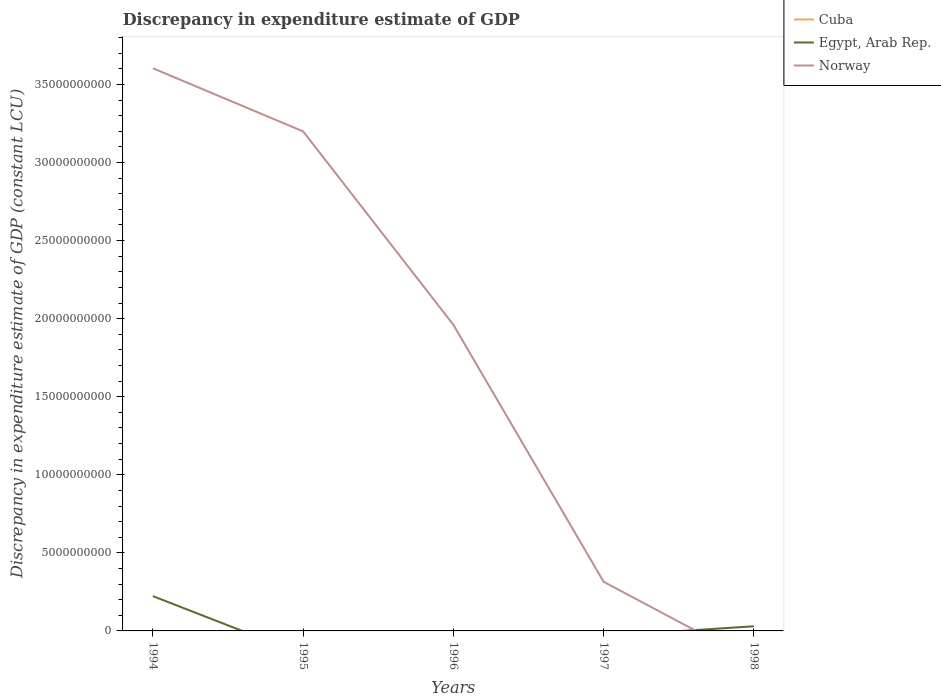How many different coloured lines are there?
Your response must be concise. 2. What is the total discrepancy in expenditure estimate of GDP in Norway in the graph?
Make the answer very short. 3.29e+1. What is the difference between the highest and the second highest discrepancy in expenditure estimate of GDP in Egypt, Arab Rep.?
Provide a succinct answer. 2.23e+09. What is the difference between the highest and the lowest discrepancy in expenditure estimate of GDP in Norway?
Keep it short and to the point. 3. Is the discrepancy in expenditure estimate of GDP in Egypt, Arab Rep. strictly greater than the discrepancy in expenditure estimate of GDP in Norway over the years?
Your answer should be very brief. No. How many lines are there?
Your response must be concise. 2. How many years are there in the graph?
Provide a succinct answer. 5. What is the difference between two consecutive major ticks on the Y-axis?
Offer a terse response. 5.00e+09. Are the values on the major ticks of Y-axis written in scientific E-notation?
Give a very brief answer. No. Does the graph contain any zero values?
Your response must be concise. Yes. Does the graph contain grids?
Provide a short and direct response. No. Where does the legend appear in the graph?
Make the answer very short. Top right. What is the title of the graph?
Offer a terse response. Discrepancy in expenditure estimate of GDP. What is the label or title of the X-axis?
Keep it short and to the point. Years. What is the label or title of the Y-axis?
Offer a terse response. Discrepancy in expenditure estimate of GDP (constant LCU). What is the Discrepancy in expenditure estimate of GDP (constant LCU) of Egypt, Arab Rep. in 1994?
Make the answer very short. 2.23e+09. What is the Discrepancy in expenditure estimate of GDP (constant LCU) in Norway in 1994?
Keep it short and to the point. 3.60e+1. What is the Discrepancy in expenditure estimate of GDP (constant LCU) in Cuba in 1995?
Your answer should be compact. 0. What is the Discrepancy in expenditure estimate of GDP (constant LCU) of Norway in 1995?
Your answer should be compact. 3.20e+1. What is the Discrepancy in expenditure estimate of GDP (constant LCU) of Cuba in 1996?
Ensure brevity in your answer.  0. What is the Discrepancy in expenditure estimate of GDP (constant LCU) in Norway in 1996?
Offer a very short reply. 1.96e+1. What is the Discrepancy in expenditure estimate of GDP (constant LCU) in Cuba in 1997?
Your answer should be compact. 0. What is the Discrepancy in expenditure estimate of GDP (constant LCU) in Egypt, Arab Rep. in 1997?
Keep it short and to the point. 0. What is the Discrepancy in expenditure estimate of GDP (constant LCU) in Norway in 1997?
Give a very brief answer. 3.15e+09. What is the Discrepancy in expenditure estimate of GDP (constant LCU) in Egypt, Arab Rep. in 1998?
Offer a terse response. 2.98e+08. Across all years, what is the maximum Discrepancy in expenditure estimate of GDP (constant LCU) of Egypt, Arab Rep.?
Your answer should be compact. 2.23e+09. Across all years, what is the maximum Discrepancy in expenditure estimate of GDP (constant LCU) of Norway?
Offer a terse response. 3.60e+1. Across all years, what is the minimum Discrepancy in expenditure estimate of GDP (constant LCU) of Norway?
Offer a terse response. 0. What is the total Discrepancy in expenditure estimate of GDP (constant LCU) of Cuba in the graph?
Give a very brief answer. 0. What is the total Discrepancy in expenditure estimate of GDP (constant LCU) in Egypt, Arab Rep. in the graph?
Make the answer very short. 2.53e+09. What is the total Discrepancy in expenditure estimate of GDP (constant LCU) of Norway in the graph?
Your answer should be very brief. 9.08e+1. What is the difference between the Discrepancy in expenditure estimate of GDP (constant LCU) in Norway in 1994 and that in 1995?
Make the answer very short. 4.04e+09. What is the difference between the Discrepancy in expenditure estimate of GDP (constant LCU) in Norway in 1994 and that in 1996?
Provide a short and direct response. 1.64e+1. What is the difference between the Discrepancy in expenditure estimate of GDP (constant LCU) in Norway in 1994 and that in 1997?
Make the answer very short. 3.29e+1. What is the difference between the Discrepancy in expenditure estimate of GDP (constant LCU) of Egypt, Arab Rep. in 1994 and that in 1998?
Ensure brevity in your answer.  1.93e+09. What is the difference between the Discrepancy in expenditure estimate of GDP (constant LCU) in Norway in 1995 and that in 1996?
Your response must be concise. 1.24e+1. What is the difference between the Discrepancy in expenditure estimate of GDP (constant LCU) in Norway in 1995 and that in 1997?
Give a very brief answer. 2.88e+1. What is the difference between the Discrepancy in expenditure estimate of GDP (constant LCU) of Norway in 1996 and that in 1997?
Offer a very short reply. 1.65e+1. What is the difference between the Discrepancy in expenditure estimate of GDP (constant LCU) in Egypt, Arab Rep. in 1994 and the Discrepancy in expenditure estimate of GDP (constant LCU) in Norway in 1995?
Your answer should be very brief. -2.98e+1. What is the difference between the Discrepancy in expenditure estimate of GDP (constant LCU) in Egypt, Arab Rep. in 1994 and the Discrepancy in expenditure estimate of GDP (constant LCU) in Norway in 1996?
Offer a very short reply. -1.74e+1. What is the difference between the Discrepancy in expenditure estimate of GDP (constant LCU) in Egypt, Arab Rep. in 1994 and the Discrepancy in expenditure estimate of GDP (constant LCU) in Norway in 1997?
Make the answer very short. -9.20e+08. What is the average Discrepancy in expenditure estimate of GDP (constant LCU) of Cuba per year?
Provide a succinct answer. 0. What is the average Discrepancy in expenditure estimate of GDP (constant LCU) in Egypt, Arab Rep. per year?
Provide a short and direct response. 5.05e+08. What is the average Discrepancy in expenditure estimate of GDP (constant LCU) of Norway per year?
Keep it short and to the point. 1.82e+1. In the year 1994, what is the difference between the Discrepancy in expenditure estimate of GDP (constant LCU) of Egypt, Arab Rep. and Discrepancy in expenditure estimate of GDP (constant LCU) of Norway?
Ensure brevity in your answer.  -3.38e+1. What is the ratio of the Discrepancy in expenditure estimate of GDP (constant LCU) in Norway in 1994 to that in 1995?
Your response must be concise. 1.13. What is the ratio of the Discrepancy in expenditure estimate of GDP (constant LCU) in Norway in 1994 to that in 1996?
Your answer should be compact. 1.84. What is the ratio of the Discrepancy in expenditure estimate of GDP (constant LCU) in Norway in 1994 to that in 1997?
Your answer should be very brief. 11.45. What is the ratio of the Discrepancy in expenditure estimate of GDP (constant LCU) in Egypt, Arab Rep. in 1994 to that in 1998?
Make the answer very short. 7.48. What is the ratio of the Discrepancy in expenditure estimate of GDP (constant LCU) in Norway in 1995 to that in 1996?
Provide a succinct answer. 1.63. What is the ratio of the Discrepancy in expenditure estimate of GDP (constant LCU) in Norway in 1995 to that in 1997?
Provide a succinct answer. 10.16. What is the ratio of the Discrepancy in expenditure estimate of GDP (constant LCU) in Norway in 1996 to that in 1997?
Offer a terse response. 6.23. What is the difference between the highest and the second highest Discrepancy in expenditure estimate of GDP (constant LCU) in Norway?
Give a very brief answer. 4.04e+09. What is the difference between the highest and the lowest Discrepancy in expenditure estimate of GDP (constant LCU) of Egypt, Arab Rep.?
Give a very brief answer. 2.23e+09. What is the difference between the highest and the lowest Discrepancy in expenditure estimate of GDP (constant LCU) in Norway?
Provide a short and direct response. 3.60e+1. 